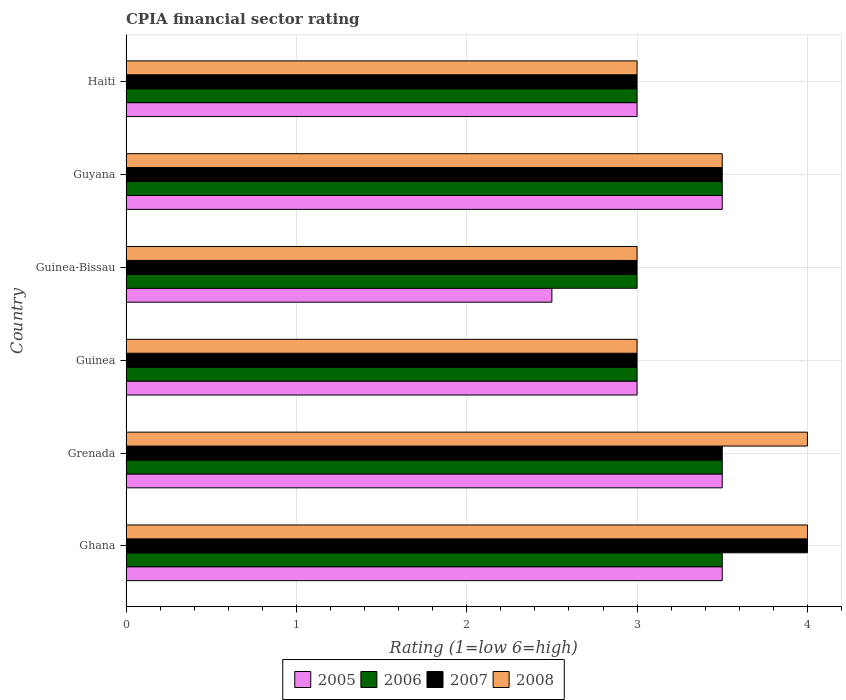How many groups of bars are there?
Provide a succinct answer. 6. Are the number of bars per tick equal to the number of legend labels?
Provide a short and direct response. Yes. Are the number of bars on each tick of the Y-axis equal?
Ensure brevity in your answer.  Yes. How many bars are there on the 6th tick from the top?
Keep it short and to the point. 4. How many bars are there on the 2nd tick from the bottom?
Provide a short and direct response. 4. What is the label of the 3rd group of bars from the top?
Provide a succinct answer. Guinea-Bissau. Across all countries, what is the maximum CPIA rating in 2006?
Make the answer very short. 3.5. Across all countries, what is the minimum CPIA rating in 2005?
Give a very brief answer. 2.5. In which country was the CPIA rating in 2005 minimum?
Give a very brief answer. Guinea-Bissau. What is the total CPIA rating in 2006 in the graph?
Make the answer very short. 19.5. What is the average CPIA rating in 2005 per country?
Your answer should be very brief. 3.17. What is the difference between the CPIA rating in 2007 and CPIA rating in 2005 in Guyana?
Your answer should be compact. 0. In how many countries, is the CPIA rating in 2008 greater than 2 ?
Your answer should be very brief. 6. What is the ratio of the CPIA rating in 2008 in Ghana to that in Haiti?
Make the answer very short. 1.33. Is the CPIA rating in 2008 in Ghana less than that in Guinea-Bissau?
Offer a very short reply. No. Is it the case that in every country, the sum of the CPIA rating in 2008 and CPIA rating in 2005 is greater than the sum of CPIA rating in 2006 and CPIA rating in 2007?
Provide a succinct answer. No. How many bars are there?
Provide a short and direct response. 24. How many countries are there in the graph?
Keep it short and to the point. 6. What is the difference between two consecutive major ticks on the X-axis?
Keep it short and to the point. 1. Are the values on the major ticks of X-axis written in scientific E-notation?
Offer a terse response. No. Does the graph contain any zero values?
Keep it short and to the point. No. Where does the legend appear in the graph?
Offer a terse response. Bottom center. What is the title of the graph?
Keep it short and to the point. CPIA financial sector rating. What is the label or title of the X-axis?
Offer a terse response. Rating (1=low 6=high). What is the Rating (1=low 6=high) of 2005 in Ghana?
Make the answer very short. 3.5. What is the Rating (1=low 6=high) of 2006 in Ghana?
Keep it short and to the point. 3.5. What is the Rating (1=low 6=high) in 2008 in Ghana?
Provide a short and direct response. 4. What is the Rating (1=low 6=high) in 2006 in Guinea?
Your response must be concise. 3. What is the Rating (1=low 6=high) of 2007 in Guinea?
Provide a short and direct response. 3. What is the Rating (1=low 6=high) in 2006 in Guinea-Bissau?
Offer a terse response. 3. What is the Rating (1=low 6=high) of 2008 in Guinea-Bissau?
Make the answer very short. 3. What is the Rating (1=low 6=high) of 2005 in Guyana?
Make the answer very short. 3.5. What is the Rating (1=low 6=high) of 2006 in Guyana?
Give a very brief answer. 3.5. What is the Rating (1=low 6=high) of 2007 in Guyana?
Provide a succinct answer. 3.5. What is the Rating (1=low 6=high) of 2005 in Haiti?
Ensure brevity in your answer.  3. What is the Rating (1=low 6=high) of 2006 in Haiti?
Keep it short and to the point. 3. What is the Rating (1=low 6=high) of 2007 in Haiti?
Provide a succinct answer. 3. Across all countries, what is the maximum Rating (1=low 6=high) in 2008?
Make the answer very short. 4. Across all countries, what is the minimum Rating (1=low 6=high) in 2005?
Offer a very short reply. 2.5. What is the total Rating (1=low 6=high) of 2007 in the graph?
Provide a succinct answer. 20. What is the difference between the Rating (1=low 6=high) of 2006 in Ghana and that in Grenada?
Ensure brevity in your answer.  0. What is the difference between the Rating (1=low 6=high) in 2007 in Ghana and that in Grenada?
Ensure brevity in your answer.  0.5. What is the difference between the Rating (1=low 6=high) of 2008 in Ghana and that in Grenada?
Your answer should be compact. 0. What is the difference between the Rating (1=low 6=high) of 2005 in Ghana and that in Guinea?
Keep it short and to the point. 0.5. What is the difference between the Rating (1=low 6=high) in 2006 in Ghana and that in Guinea?
Your response must be concise. 0.5. What is the difference between the Rating (1=low 6=high) of 2005 in Ghana and that in Guinea-Bissau?
Provide a succinct answer. 1. What is the difference between the Rating (1=low 6=high) of 2008 in Ghana and that in Guinea-Bissau?
Your answer should be very brief. 1. What is the difference between the Rating (1=low 6=high) of 2006 in Ghana and that in Guyana?
Provide a succinct answer. 0. What is the difference between the Rating (1=low 6=high) of 2007 in Ghana and that in Guyana?
Your answer should be compact. 0.5. What is the difference between the Rating (1=low 6=high) of 2008 in Ghana and that in Guyana?
Ensure brevity in your answer.  0.5. What is the difference between the Rating (1=low 6=high) in 2007 in Ghana and that in Haiti?
Your response must be concise. 1. What is the difference between the Rating (1=low 6=high) in 2008 in Grenada and that in Guinea?
Offer a terse response. 1. What is the difference between the Rating (1=low 6=high) in 2007 in Grenada and that in Guinea-Bissau?
Provide a succinct answer. 0.5. What is the difference between the Rating (1=low 6=high) of 2008 in Grenada and that in Guinea-Bissau?
Make the answer very short. 1. What is the difference between the Rating (1=low 6=high) in 2005 in Grenada and that in Guyana?
Keep it short and to the point. 0. What is the difference between the Rating (1=low 6=high) in 2007 in Grenada and that in Guyana?
Provide a succinct answer. 0. What is the difference between the Rating (1=low 6=high) of 2005 in Grenada and that in Haiti?
Your answer should be compact. 0.5. What is the difference between the Rating (1=low 6=high) of 2006 in Grenada and that in Haiti?
Your answer should be very brief. 0.5. What is the difference between the Rating (1=low 6=high) in 2008 in Grenada and that in Haiti?
Provide a succinct answer. 1. What is the difference between the Rating (1=low 6=high) of 2005 in Guinea and that in Guinea-Bissau?
Offer a terse response. 0.5. What is the difference between the Rating (1=low 6=high) of 2006 in Guinea and that in Guinea-Bissau?
Ensure brevity in your answer.  0. What is the difference between the Rating (1=low 6=high) in 2007 in Guinea and that in Guinea-Bissau?
Your answer should be compact. 0. What is the difference between the Rating (1=low 6=high) of 2005 in Guinea and that in Guyana?
Ensure brevity in your answer.  -0.5. What is the difference between the Rating (1=low 6=high) of 2007 in Guinea and that in Guyana?
Your response must be concise. -0.5. What is the difference between the Rating (1=low 6=high) of 2005 in Guinea and that in Haiti?
Your response must be concise. 0. What is the difference between the Rating (1=low 6=high) in 2006 in Guinea and that in Haiti?
Offer a terse response. 0. What is the difference between the Rating (1=low 6=high) of 2008 in Guinea and that in Haiti?
Keep it short and to the point. 0. What is the difference between the Rating (1=low 6=high) in 2007 in Guinea-Bissau and that in Guyana?
Ensure brevity in your answer.  -0.5. What is the difference between the Rating (1=low 6=high) of 2005 in Guinea-Bissau and that in Haiti?
Ensure brevity in your answer.  -0.5. What is the difference between the Rating (1=low 6=high) of 2006 in Guinea-Bissau and that in Haiti?
Provide a short and direct response. 0. What is the difference between the Rating (1=low 6=high) of 2007 in Guinea-Bissau and that in Haiti?
Provide a succinct answer. 0. What is the difference between the Rating (1=low 6=high) of 2008 in Guinea-Bissau and that in Haiti?
Provide a short and direct response. 0. What is the difference between the Rating (1=low 6=high) of 2005 in Guyana and that in Haiti?
Your response must be concise. 0.5. What is the difference between the Rating (1=low 6=high) of 2006 in Guyana and that in Haiti?
Your response must be concise. 0.5. What is the difference between the Rating (1=low 6=high) of 2005 in Ghana and the Rating (1=low 6=high) of 2007 in Grenada?
Provide a short and direct response. 0. What is the difference between the Rating (1=low 6=high) of 2006 in Ghana and the Rating (1=low 6=high) of 2007 in Grenada?
Keep it short and to the point. 0. What is the difference between the Rating (1=low 6=high) in 2006 in Ghana and the Rating (1=low 6=high) in 2008 in Grenada?
Give a very brief answer. -0.5. What is the difference between the Rating (1=low 6=high) in 2007 in Ghana and the Rating (1=low 6=high) in 2008 in Grenada?
Keep it short and to the point. 0. What is the difference between the Rating (1=low 6=high) in 2005 in Ghana and the Rating (1=low 6=high) in 2006 in Guinea?
Your response must be concise. 0.5. What is the difference between the Rating (1=low 6=high) of 2005 in Ghana and the Rating (1=low 6=high) of 2008 in Guinea?
Offer a terse response. 0.5. What is the difference between the Rating (1=low 6=high) of 2007 in Ghana and the Rating (1=low 6=high) of 2008 in Guinea?
Provide a succinct answer. 1. What is the difference between the Rating (1=low 6=high) in 2005 in Ghana and the Rating (1=low 6=high) in 2006 in Guinea-Bissau?
Provide a succinct answer. 0.5. What is the difference between the Rating (1=low 6=high) in 2005 in Ghana and the Rating (1=low 6=high) in 2008 in Guinea-Bissau?
Give a very brief answer. 0.5. What is the difference between the Rating (1=low 6=high) in 2006 in Ghana and the Rating (1=low 6=high) in 2008 in Guinea-Bissau?
Your response must be concise. 0.5. What is the difference between the Rating (1=low 6=high) of 2007 in Ghana and the Rating (1=low 6=high) of 2008 in Guinea-Bissau?
Your response must be concise. 1. What is the difference between the Rating (1=low 6=high) in 2005 in Ghana and the Rating (1=low 6=high) in 2007 in Guyana?
Your answer should be compact. 0. What is the difference between the Rating (1=low 6=high) in 2005 in Ghana and the Rating (1=low 6=high) in 2008 in Guyana?
Provide a short and direct response. 0. What is the difference between the Rating (1=low 6=high) in 2006 in Ghana and the Rating (1=low 6=high) in 2008 in Guyana?
Offer a terse response. 0. What is the difference between the Rating (1=low 6=high) of 2005 in Ghana and the Rating (1=low 6=high) of 2006 in Haiti?
Keep it short and to the point. 0.5. What is the difference between the Rating (1=low 6=high) of 2005 in Ghana and the Rating (1=low 6=high) of 2007 in Haiti?
Offer a terse response. 0.5. What is the difference between the Rating (1=low 6=high) in 2006 in Ghana and the Rating (1=low 6=high) in 2008 in Haiti?
Ensure brevity in your answer.  0.5. What is the difference between the Rating (1=low 6=high) of 2007 in Ghana and the Rating (1=low 6=high) of 2008 in Haiti?
Ensure brevity in your answer.  1. What is the difference between the Rating (1=low 6=high) in 2005 in Grenada and the Rating (1=low 6=high) in 2006 in Guinea?
Provide a short and direct response. 0.5. What is the difference between the Rating (1=low 6=high) of 2005 in Grenada and the Rating (1=low 6=high) of 2007 in Guinea?
Your response must be concise. 0.5. What is the difference between the Rating (1=low 6=high) in 2006 in Grenada and the Rating (1=low 6=high) in 2007 in Guinea?
Give a very brief answer. 0.5. What is the difference between the Rating (1=low 6=high) of 2006 in Grenada and the Rating (1=low 6=high) of 2008 in Guinea?
Keep it short and to the point. 0.5. What is the difference between the Rating (1=low 6=high) in 2007 in Grenada and the Rating (1=low 6=high) in 2008 in Guinea?
Give a very brief answer. 0.5. What is the difference between the Rating (1=low 6=high) in 2006 in Grenada and the Rating (1=low 6=high) in 2008 in Guinea-Bissau?
Provide a succinct answer. 0.5. What is the difference between the Rating (1=low 6=high) of 2005 in Grenada and the Rating (1=low 6=high) of 2007 in Guyana?
Provide a short and direct response. 0. What is the difference between the Rating (1=low 6=high) in 2005 in Grenada and the Rating (1=low 6=high) in 2008 in Guyana?
Offer a very short reply. 0. What is the difference between the Rating (1=low 6=high) of 2007 in Grenada and the Rating (1=low 6=high) of 2008 in Guyana?
Provide a succinct answer. 0. What is the difference between the Rating (1=low 6=high) of 2005 in Grenada and the Rating (1=low 6=high) of 2007 in Haiti?
Give a very brief answer. 0.5. What is the difference between the Rating (1=low 6=high) in 2006 in Grenada and the Rating (1=low 6=high) in 2007 in Haiti?
Make the answer very short. 0.5. What is the difference between the Rating (1=low 6=high) in 2005 in Guinea and the Rating (1=low 6=high) in 2006 in Guyana?
Offer a terse response. -0.5. What is the difference between the Rating (1=low 6=high) of 2005 in Guinea and the Rating (1=low 6=high) of 2008 in Guyana?
Give a very brief answer. -0.5. What is the difference between the Rating (1=low 6=high) in 2006 in Guinea and the Rating (1=low 6=high) in 2007 in Guyana?
Make the answer very short. -0.5. What is the difference between the Rating (1=low 6=high) in 2006 in Guinea and the Rating (1=low 6=high) in 2008 in Guyana?
Offer a terse response. -0.5. What is the difference between the Rating (1=low 6=high) of 2005 in Guinea and the Rating (1=low 6=high) of 2006 in Haiti?
Ensure brevity in your answer.  0. What is the difference between the Rating (1=low 6=high) in 2007 in Guinea and the Rating (1=low 6=high) in 2008 in Haiti?
Make the answer very short. 0. What is the difference between the Rating (1=low 6=high) of 2006 in Guinea-Bissau and the Rating (1=low 6=high) of 2007 in Guyana?
Your answer should be very brief. -0.5. What is the difference between the Rating (1=low 6=high) of 2006 in Guinea-Bissau and the Rating (1=low 6=high) of 2008 in Haiti?
Keep it short and to the point. 0. What is the difference between the Rating (1=low 6=high) in 2007 in Guinea-Bissau and the Rating (1=low 6=high) in 2008 in Haiti?
Keep it short and to the point. 0. What is the difference between the Rating (1=low 6=high) in 2005 in Guyana and the Rating (1=low 6=high) in 2006 in Haiti?
Keep it short and to the point. 0.5. What is the difference between the Rating (1=low 6=high) in 2006 in Guyana and the Rating (1=low 6=high) in 2008 in Haiti?
Keep it short and to the point. 0.5. What is the difference between the Rating (1=low 6=high) in 2007 in Guyana and the Rating (1=low 6=high) in 2008 in Haiti?
Provide a succinct answer. 0.5. What is the average Rating (1=low 6=high) in 2005 per country?
Offer a terse response. 3.17. What is the average Rating (1=low 6=high) in 2007 per country?
Keep it short and to the point. 3.33. What is the average Rating (1=low 6=high) in 2008 per country?
Keep it short and to the point. 3.42. What is the difference between the Rating (1=low 6=high) of 2005 and Rating (1=low 6=high) of 2006 in Ghana?
Your answer should be very brief. 0. What is the difference between the Rating (1=low 6=high) of 2005 and Rating (1=low 6=high) of 2007 in Ghana?
Ensure brevity in your answer.  -0.5. What is the difference between the Rating (1=low 6=high) of 2006 and Rating (1=low 6=high) of 2007 in Ghana?
Make the answer very short. -0.5. What is the difference between the Rating (1=low 6=high) in 2005 and Rating (1=low 6=high) in 2006 in Grenada?
Make the answer very short. 0. What is the difference between the Rating (1=low 6=high) of 2006 and Rating (1=low 6=high) of 2007 in Grenada?
Your response must be concise. 0. What is the difference between the Rating (1=low 6=high) of 2007 and Rating (1=low 6=high) of 2008 in Grenada?
Make the answer very short. -0.5. What is the difference between the Rating (1=low 6=high) in 2006 and Rating (1=low 6=high) in 2007 in Guinea?
Provide a succinct answer. 0. What is the difference between the Rating (1=low 6=high) in 2007 and Rating (1=low 6=high) in 2008 in Guinea?
Provide a short and direct response. 0. What is the difference between the Rating (1=low 6=high) in 2005 and Rating (1=low 6=high) in 2006 in Guinea-Bissau?
Offer a very short reply. -0.5. What is the difference between the Rating (1=low 6=high) of 2005 and Rating (1=low 6=high) of 2007 in Guinea-Bissau?
Provide a short and direct response. -0.5. What is the difference between the Rating (1=low 6=high) of 2005 and Rating (1=low 6=high) of 2008 in Guinea-Bissau?
Make the answer very short. -0.5. What is the difference between the Rating (1=low 6=high) of 2006 and Rating (1=low 6=high) of 2007 in Guinea-Bissau?
Your answer should be compact. 0. What is the difference between the Rating (1=low 6=high) in 2007 and Rating (1=low 6=high) in 2008 in Guinea-Bissau?
Offer a terse response. 0. What is the difference between the Rating (1=low 6=high) of 2006 and Rating (1=low 6=high) of 2008 in Guyana?
Give a very brief answer. 0. What is the difference between the Rating (1=low 6=high) in 2007 and Rating (1=low 6=high) in 2008 in Guyana?
Offer a very short reply. 0. What is the difference between the Rating (1=low 6=high) in 2005 and Rating (1=low 6=high) in 2006 in Haiti?
Make the answer very short. 0. What is the difference between the Rating (1=low 6=high) of 2005 and Rating (1=low 6=high) of 2008 in Haiti?
Offer a terse response. 0. What is the difference between the Rating (1=low 6=high) in 2007 and Rating (1=low 6=high) in 2008 in Haiti?
Make the answer very short. 0. What is the ratio of the Rating (1=low 6=high) of 2005 in Ghana to that in Grenada?
Your answer should be very brief. 1. What is the ratio of the Rating (1=low 6=high) in 2006 in Ghana to that in Grenada?
Your response must be concise. 1. What is the ratio of the Rating (1=low 6=high) of 2007 in Ghana to that in Grenada?
Provide a succinct answer. 1.14. What is the ratio of the Rating (1=low 6=high) in 2008 in Ghana to that in Grenada?
Your response must be concise. 1. What is the ratio of the Rating (1=low 6=high) in 2006 in Ghana to that in Guinea-Bissau?
Your answer should be compact. 1.17. What is the ratio of the Rating (1=low 6=high) of 2008 in Ghana to that in Guinea-Bissau?
Make the answer very short. 1.33. What is the ratio of the Rating (1=low 6=high) in 2005 in Ghana to that in Guyana?
Provide a short and direct response. 1. What is the ratio of the Rating (1=low 6=high) of 2006 in Ghana to that in Guyana?
Your response must be concise. 1. What is the ratio of the Rating (1=low 6=high) in 2007 in Ghana to that in Guyana?
Provide a succinct answer. 1.14. What is the ratio of the Rating (1=low 6=high) of 2007 in Ghana to that in Haiti?
Offer a terse response. 1.33. What is the ratio of the Rating (1=low 6=high) of 2006 in Grenada to that in Guinea?
Make the answer very short. 1.17. What is the ratio of the Rating (1=low 6=high) of 2007 in Grenada to that in Guinea?
Ensure brevity in your answer.  1.17. What is the ratio of the Rating (1=low 6=high) of 2005 in Grenada to that in Guinea-Bissau?
Your answer should be very brief. 1.4. What is the ratio of the Rating (1=low 6=high) in 2006 in Grenada to that in Guinea-Bissau?
Your response must be concise. 1.17. What is the ratio of the Rating (1=low 6=high) of 2007 in Grenada to that in Guinea-Bissau?
Offer a very short reply. 1.17. What is the ratio of the Rating (1=low 6=high) in 2008 in Grenada to that in Guyana?
Provide a succinct answer. 1.14. What is the ratio of the Rating (1=low 6=high) in 2008 in Guinea to that in Guinea-Bissau?
Offer a terse response. 1. What is the ratio of the Rating (1=low 6=high) of 2005 in Guinea to that in Guyana?
Offer a terse response. 0.86. What is the ratio of the Rating (1=low 6=high) of 2006 in Guinea to that in Guyana?
Provide a succinct answer. 0.86. What is the ratio of the Rating (1=low 6=high) in 2008 in Guinea to that in Guyana?
Your answer should be very brief. 0.86. What is the ratio of the Rating (1=low 6=high) in 2006 in Guinea to that in Haiti?
Provide a succinct answer. 1. What is the ratio of the Rating (1=low 6=high) in 2007 in Guinea to that in Haiti?
Provide a short and direct response. 1. What is the ratio of the Rating (1=low 6=high) of 2005 in Guinea-Bissau to that in Guyana?
Offer a terse response. 0.71. What is the ratio of the Rating (1=low 6=high) of 2007 in Guinea-Bissau to that in Guyana?
Offer a terse response. 0.86. What is the ratio of the Rating (1=low 6=high) in 2008 in Guinea-Bissau to that in Guyana?
Offer a very short reply. 0.86. What is the ratio of the Rating (1=low 6=high) of 2006 in Guinea-Bissau to that in Haiti?
Your response must be concise. 1. What is the ratio of the Rating (1=low 6=high) of 2007 in Guinea-Bissau to that in Haiti?
Your response must be concise. 1. What is the ratio of the Rating (1=low 6=high) in 2005 in Guyana to that in Haiti?
Your answer should be compact. 1.17. What is the ratio of the Rating (1=low 6=high) in 2006 in Guyana to that in Haiti?
Give a very brief answer. 1.17. What is the ratio of the Rating (1=low 6=high) of 2007 in Guyana to that in Haiti?
Keep it short and to the point. 1.17. What is the difference between the highest and the second highest Rating (1=low 6=high) of 2007?
Ensure brevity in your answer.  0.5. What is the difference between the highest and the second highest Rating (1=low 6=high) in 2008?
Your response must be concise. 0. What is the difference between the highest and the lowest Rating (1=low 6=high) in 2005?
Your answer should be very brief. 1. What is the difference between the highest and the lowest Rating (1=low 6=high) in 2006?
Ensure brevity in your answer.  0.5. What is the difference between the highest and the lowest Rating (1=low 6=high) of 2007?
Give a very brief answer. 1. What is the difference between the highest and the lowest Rating (1=low 6=high) of 2008?
Ensure brevity in your answer.  1. 